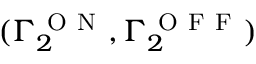<formula> <loc_0><loc_0><loc_500><loc_500>( \Gamma _ { 2 } ^ { O N } , \Gamma _ { 2 } ^ { O F F } )</formula> 